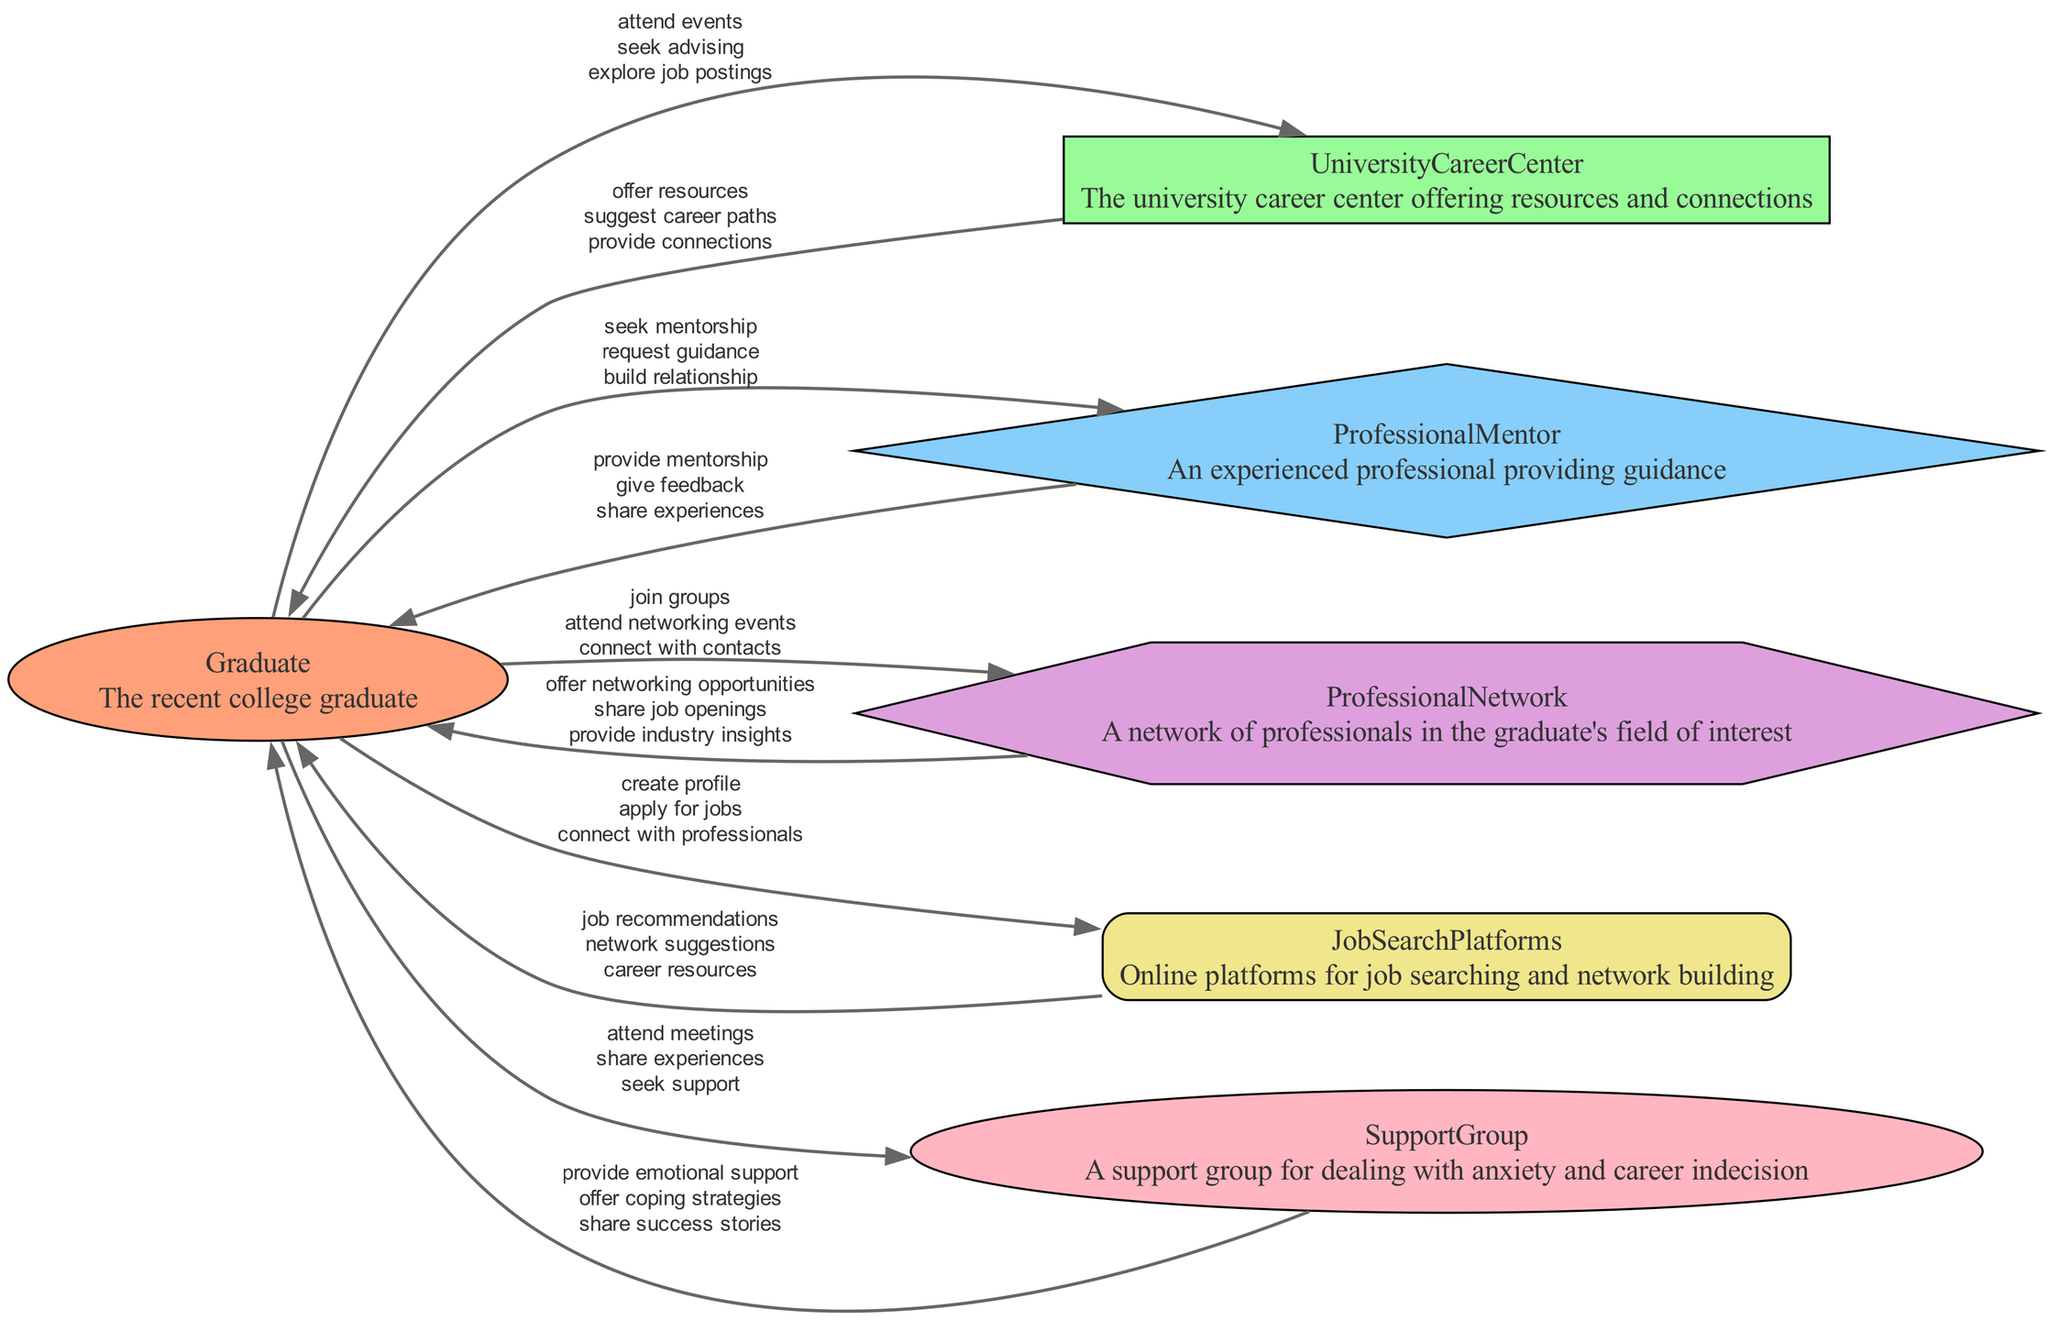what is the primary function of the University Career Center? The University Career Center offers resources and connections for graduates, helping them to explore job opportunities and guiding them in their careers.
Answer: resources and connections how many interactions does the Graduate have with the Professional Mentor? The diagram shows three data flows between the Graduate and the Professional Mentor, indicating multiple interactions for seeking mentorship, requesting guidance, and building a relationship.
Answer: three which entity provides emotional support to the Graduate? The Support Group is specifically designed to provide emotional support and coping strategies for the Graduate, helping them deal with anxiety and career indecision.
Answer: Support Group what type of connection does the Graduate make with the Job Search Platforms? The Graduate connects with Job Search Platforms by creating a profile, applying for jobs, and connecting with professionals to facilitate their job search efforts.
Answer: connect which group offers job recommendations to the Graduate? The Job Search Platforms provide job recommendations, along with network suggestions and career resources to assist the Graduate in their job search.
Answer: Job Search Platforms describe the relationship flow from the Graduate to Professional Network. The Graduate interacts with the Professional Network by joining groups, attending networking events, and connecting with contacts, enhancing their professional opportunities.
Answer: join groups, attend networking events, connect with contacts what does the Professional Mentor provide to the Graduate? The Professional Mentor provides mentorship, gives feedback, and shares experiences to guide the Graduate in their career journey.
Answer: mentorship, feedback, experiences how does the Graduate benefit from the University Career Center? The Graduate benefits from the University Career Center by receiving resources, suggestions for career paths, and connections to industry professionals, which helps in career decision-making.
Answer: resources, career paths, connections what shape represents the Graduate in the diagram? The Graduate is represented as an ellipse in the data flow diagram, visually differentiating them from other entities like the University Career Center and Professional Mentor.
Answer: ellipse 